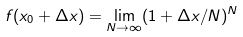Convert formula to latex. <formula><loc_0><loc_0><loc_500><loc_500>f ( x _ { 0 } + \Delta x ) = \lim _ { N \rightarrow \infty } ( 1 + \Delta x / N ) ^ { N }</formula> 